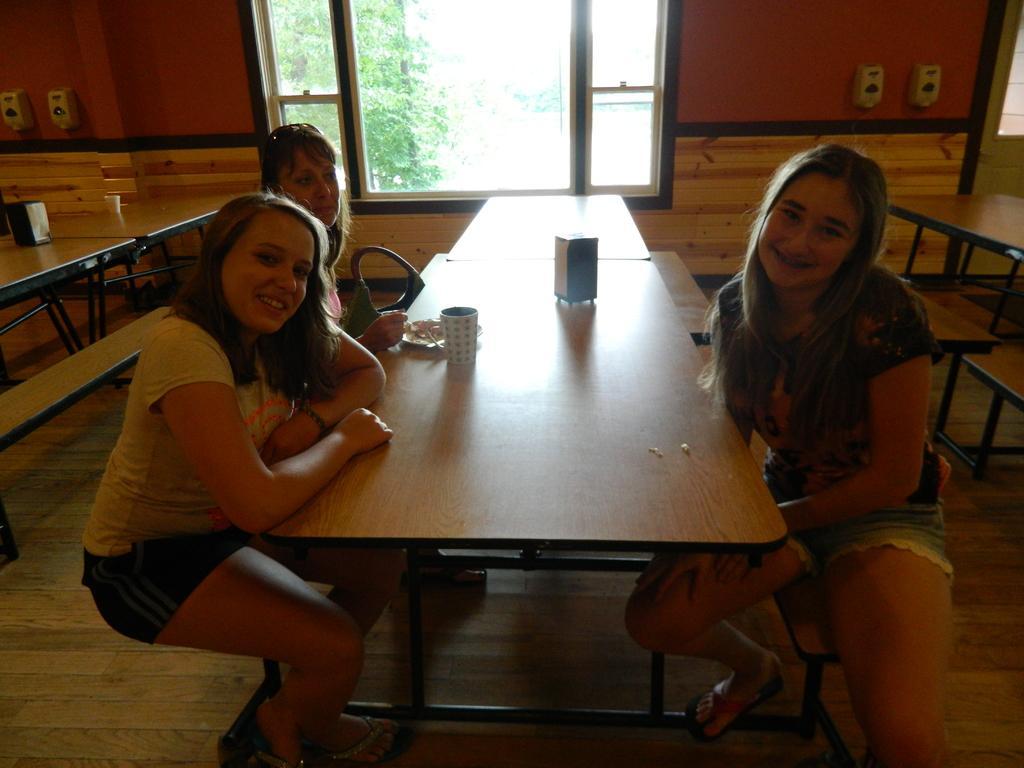How would you summarize this image in a sentence or two? In this image i can see 3 women sitting on chairs in front of a table, on the table i can see a coffee cup and few other objects. In the background i can see a window a wall and trees. 